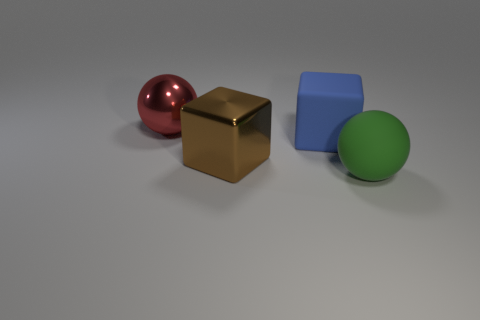Add 1 big red balls. How many objects exist? 5 Add 2 big red balls. How many big red balls are left? 3 Add 1 large things. How many large things exist? 5 Subtract 1 red spheres. How many objects are left? 3 Subtract all big purple rubber cubes. Subtract all blue objects. How many objects are left? 3 